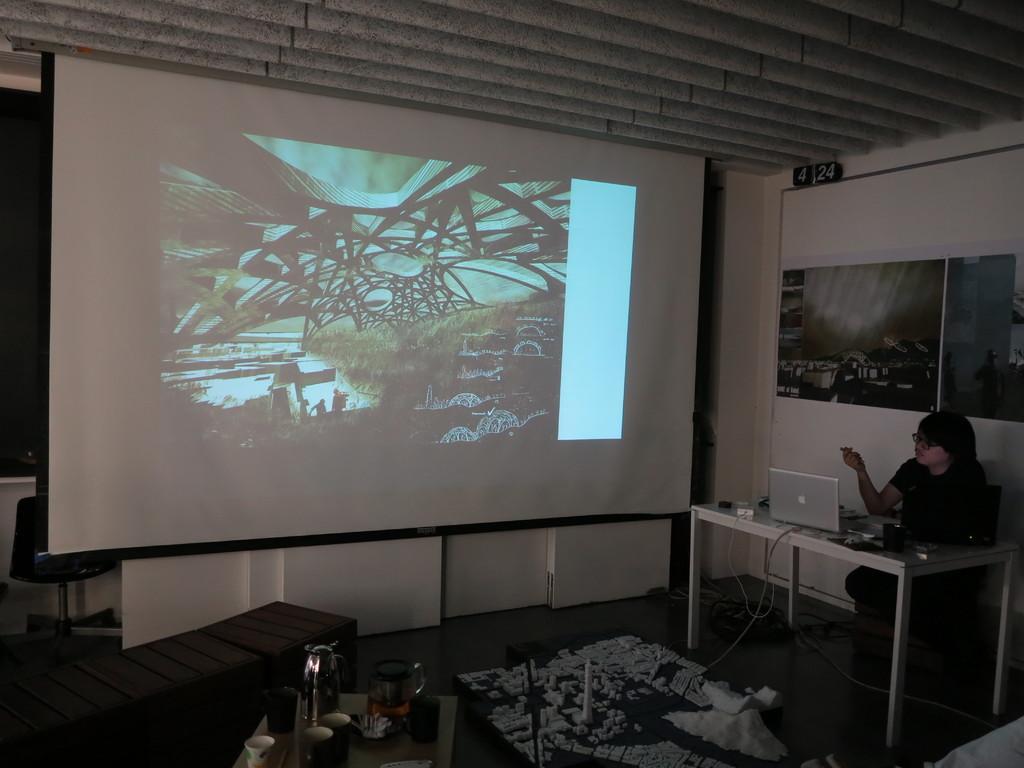Describe this image in one or two sentences. In the right side of the image I can see a person sitting on the chair. This is a table with a laptop and some objects on it. This is a foldable screen with a image on it. I think these are the posters attached to the wall. This looks like a teapot where there is a jug,cup and some other things on it. I can see a chair behind the screen. 